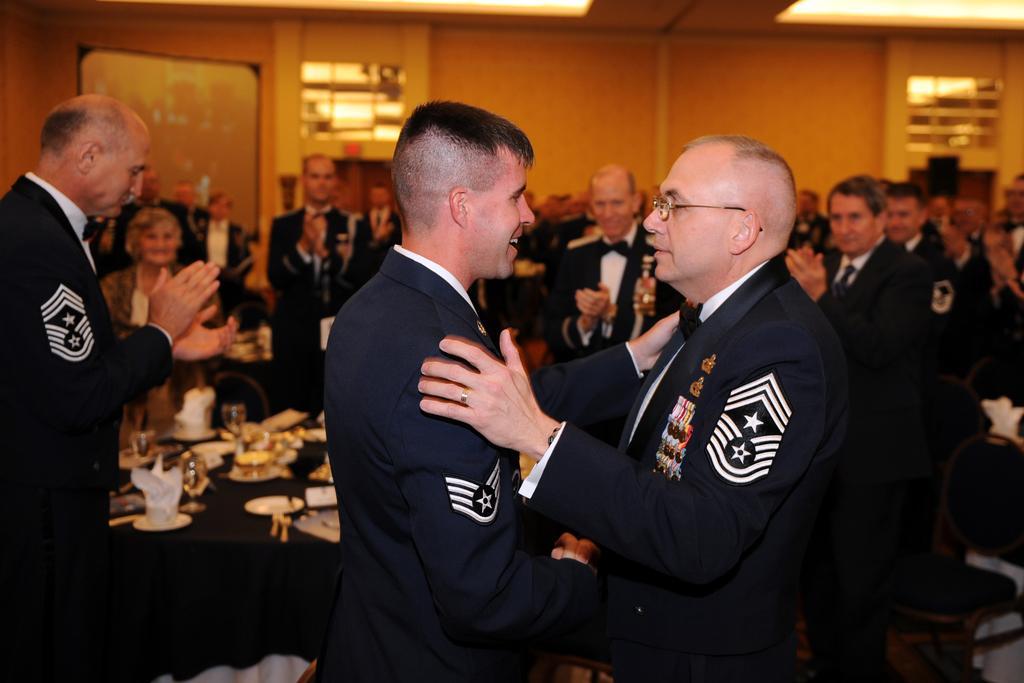Could you give a brief overview of what you see in this image? In the foreground of the image there are two people wearing blue color suits. In the background of the image there are people standing and clapping. There is a table on which there are glasses and other objects. In the background of the image there is wall. At the top of the image there is ceiling with lights. 